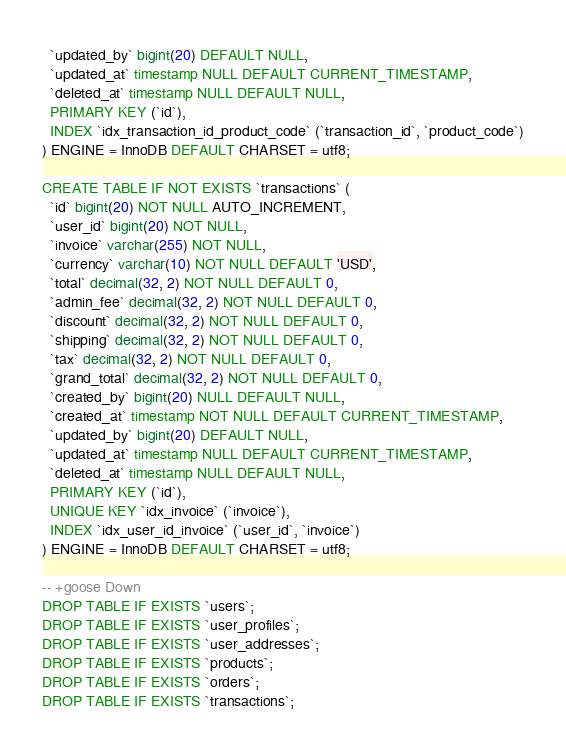Convert code to text. <code><loc_0><loc_0><loc_500><loc_500><_SQL_>  `updated_by` bigint(20) DEFAULT NULL,
  `updated_at` timestamp NULL DEFAULT CURRENT_TIMESTAMP,
  `deleted_at` timestamp NULL DEFAULT NULL,
  PRIMARY KEY (`id`),
  INDEX `idx_transaction_id_product_code` (`transaction_id`, `product_code`)
) ENGINE = InnoDB DEFAULT CHARSET = utf8;

CREATE TABLE IF NOT EXISTS `transactions` (
  `id` bigint(20) NOT NULL AUTO_INCREMENT,
  `user_id` bigint(20) NOT NULL,
  `invoice` varchar(255) NOT NULL,
  `currency` varchar(10) NOT NULL DEFAULT 'USD',
  `total` decimal(32, 2) NOT NULL DEFAULT 0,
  `admin_fee` decimal(32, 2) NOT NULL DEFAULT 0,
  `discount` decimal(32, 2) NOT NULL DEFAULT 0,
  `shipping` decimal(32, 2) NOT NULL DEFAULT 0,
  `tax` decimal(32, 2) NOT NULL DEFAULT 0,
  `grand_total` decimal(32, 2) NOT NULL DEFAULT 0,
  `created_by` bigint(20) NULL DEFAULT NULL,
  `created_at` timestamp NOT NULL DEFAULT CURRENT_TIMESTAMP,
  `updated_by` bigint(20) DEFAULT NULL,
  `updated_at` timestamp NULL DEFAULT CURRENT_TIMESTAMP,
  `deleted_at` timestamp NULL DEFAULT NULL,
  PRIMARY KEY (`id`),
  UNIQUE KEY `idx_invoice` (`invoice`),
  INDEX `idx_user_id_invoice` (`user_id`, `invoice`)
) ENGINE = InnoDB DEFAULT CHARSET = utf8;

-- +goose Down
DROP TABLE IF EXISTS `users`;
DROP TABLE IF EXISTS `user_profiles`;
DROP TABLE IF EXISTS `user_addresses`;
DROP TABLE IF EXISTS `products`;
DROP TABLE IF EXISTS `orders`;
DROP TABLE IF EXISTS `transactions`;</code> 